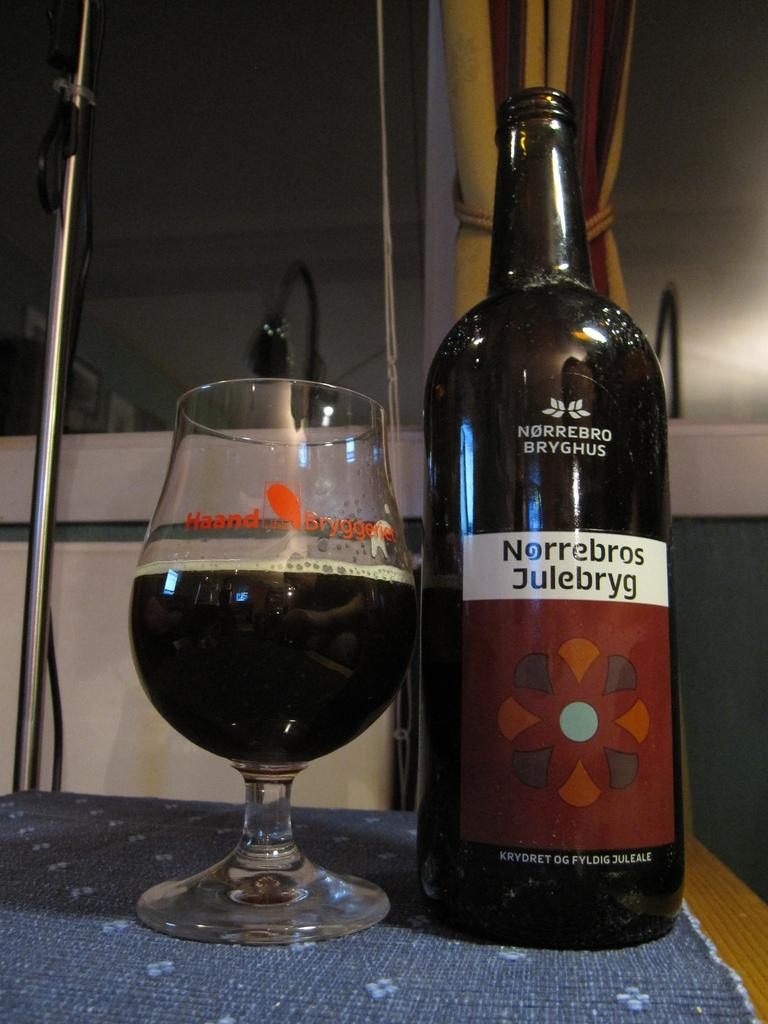<image>
Write a terse but informative summary of the picture. A bottle of Norrebros Julebryg is sitting next to a partially filled wine glass. 